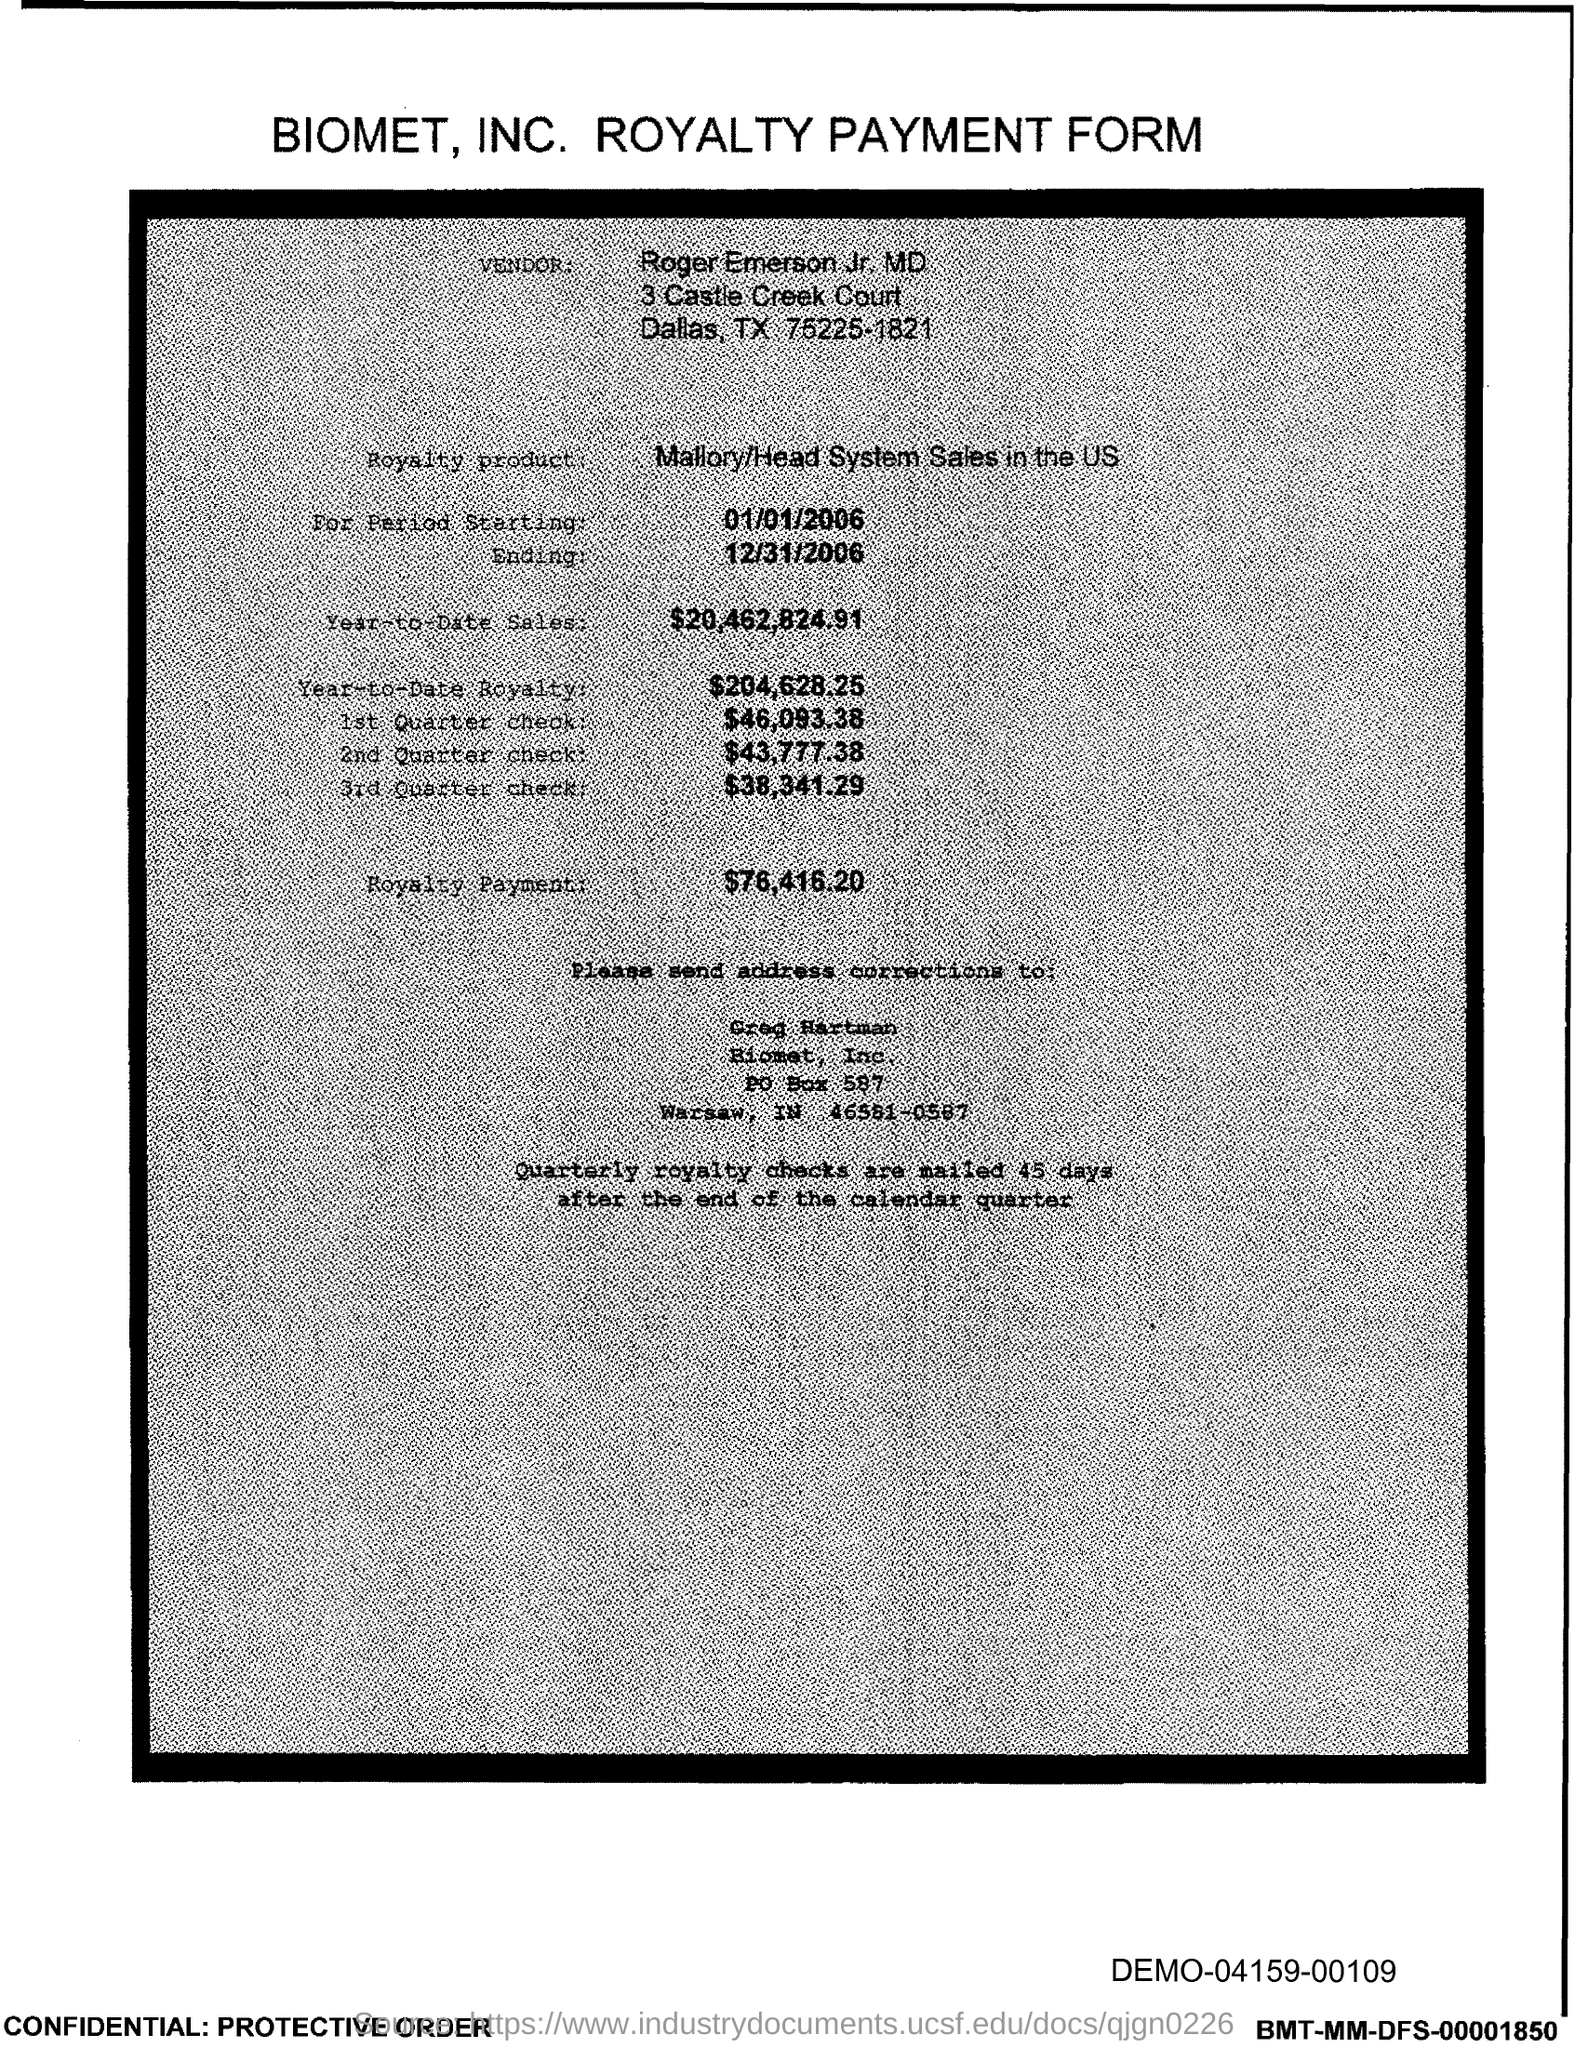Outline some significant characteristics in this image. The document indicates a PO Box number of 587. 